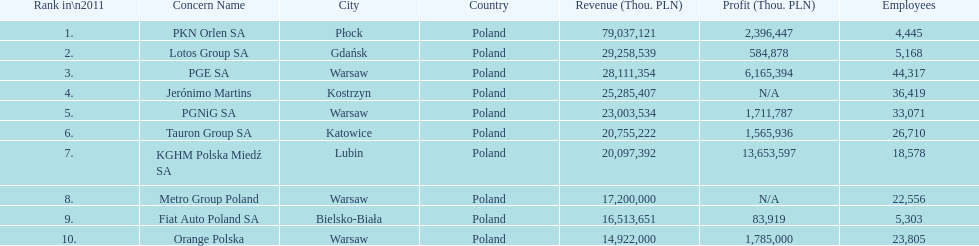What company is the only one with a revenue greater than 75,000,000 thou. pln? PKN Orlen SA. 